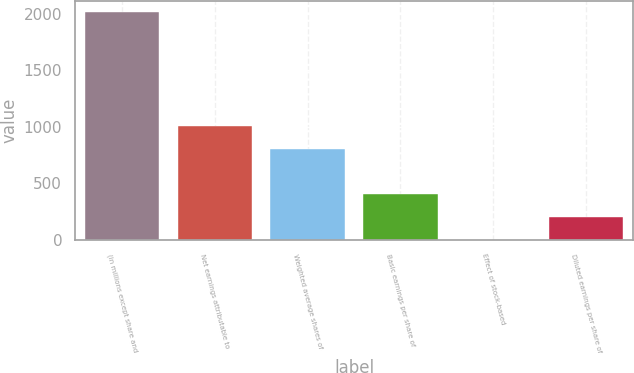<chart> <loc_0><loc_0><loc_500><loc_500><bar_chart><fcel>(in millions except share and<fcel>Net earnings attributable to<fcel>Weighted average shares of<fcel>Basic earnings per share of<fcel>Effect of stock-based<fcel>Diluted earnings per share of<nl><fcel>2016<fcel>1008.47<fcel>806.96<fcel>403.95<fcel>0.95<fcel>202.45<nl></chart> 